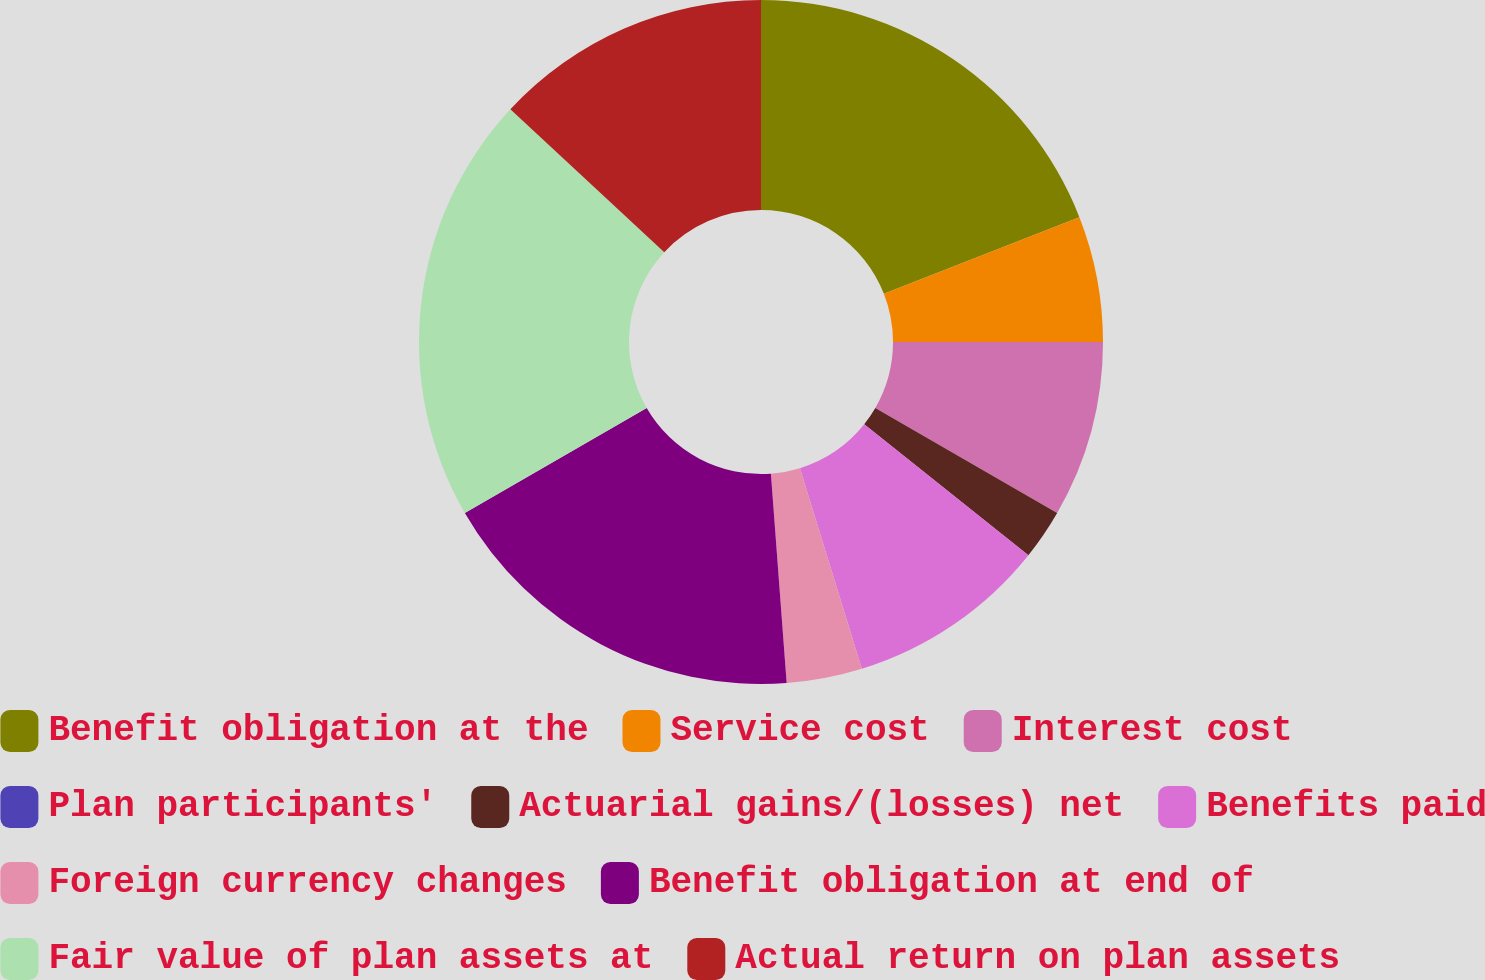<chart> <loc_0><loc_0><loc_500><loc_500><pie_chart><fcel>Benefit obligation at the<fcel>Service cost<fcel>Interest cost<fcel>Plan participants'<fcel>Actuarial gains/(losses) net<fcel>Benefits paid<fcel>Foreign currency changes<fcel>Benefit obligation at end of<fcel>Fair value of plan assets at<fcel>Actual return on plan assets<nl><fcel>19.05%<fcel>5.95%<fcel>8.33%<fcel>0.0%<fcel>2.38%<fcel>9.52%<fcel>3.57%<fcel>17.86%<fcel>20.24%<fcel>13.09%<nl></chart> 